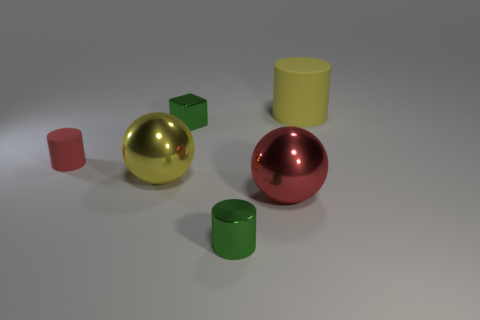Subtract all tiny red rubber cylinders. How many cylinders are left? 2 Subtract all green cylinders. How many cylinders are left? 2 Add 4 tiny green cubes. How many objects exist? 10 Subtract all spheres. How many objects are left? 4 Subtract 1 blocks. How many blocks are left? 0 Subtract all blue cylinders. Subtract all yellow spheres. How many cylinders are left? 3 Add 2 small red cylinders. How many small red cylinders exist? 3 Subtract 0 purple balls. How many objects are left? 6 Subtract all red blocks. How many green cylinders are left? 1 Subtract all yellow cylinders. Subtract all green metal things. How many objects are left? 3 